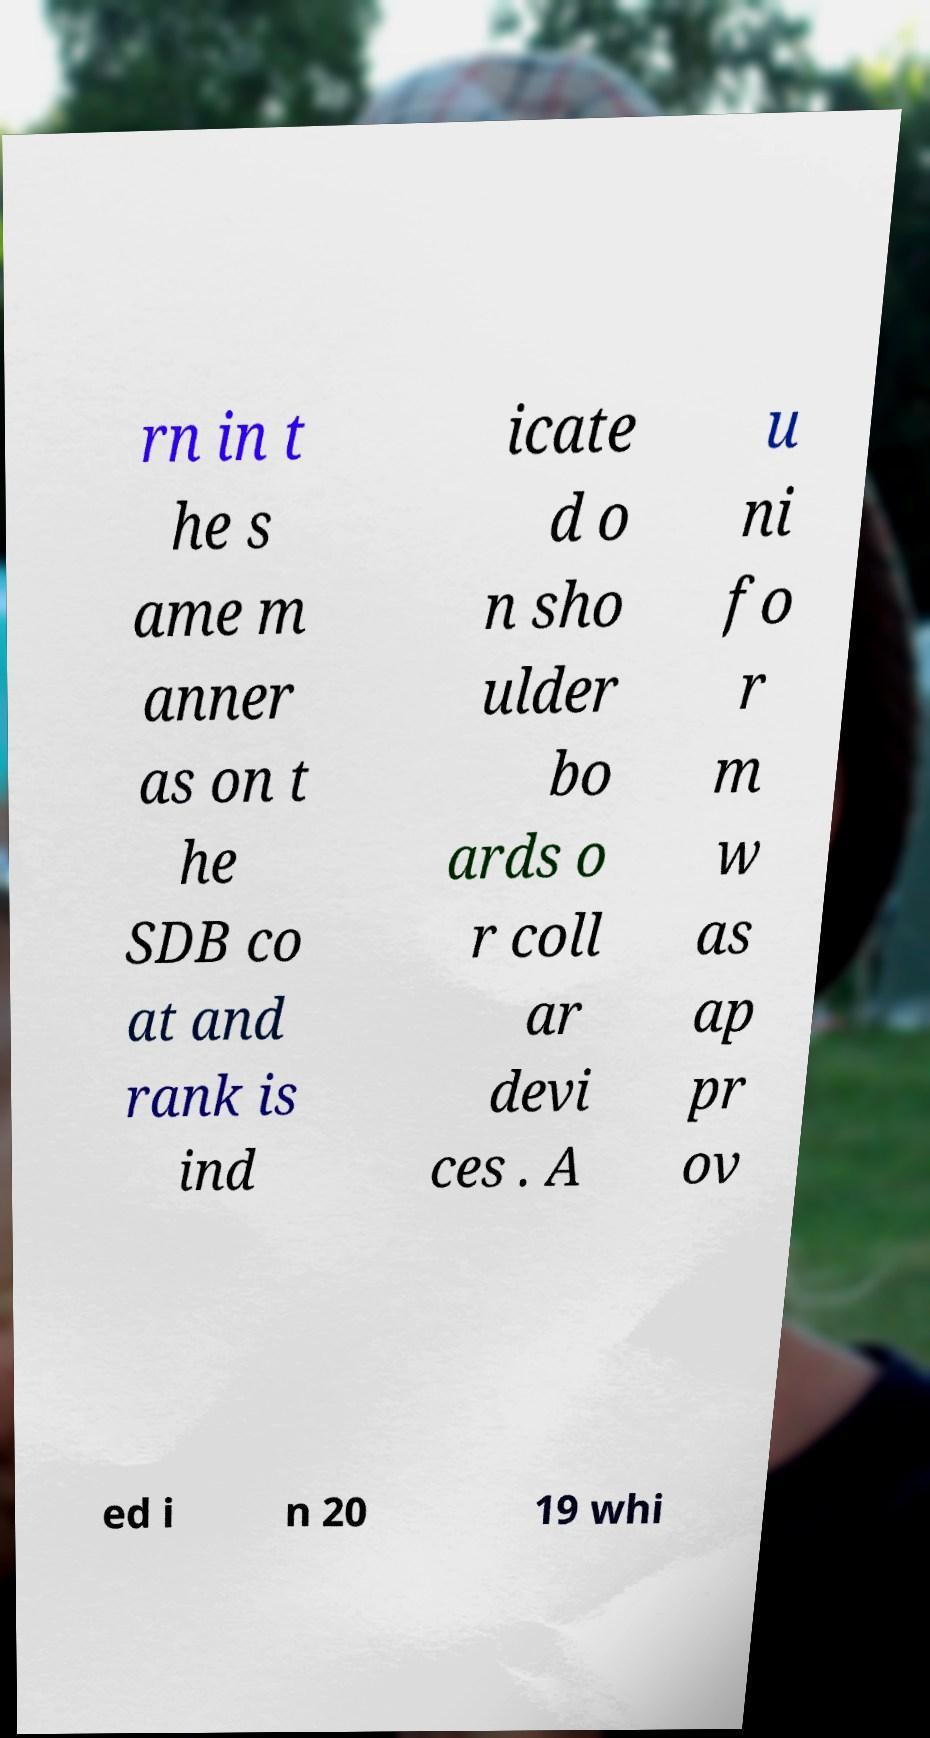For documentation purposes, I need the text within this image transcribed. Could you provide that? rn in t he s ame m anner as on t he SDB co at and rank is ind icate d o n sho ulder bo ards o r coll ar devi ces . A u ni fo r m w as ap pr ov ed i n 20 19 whi 